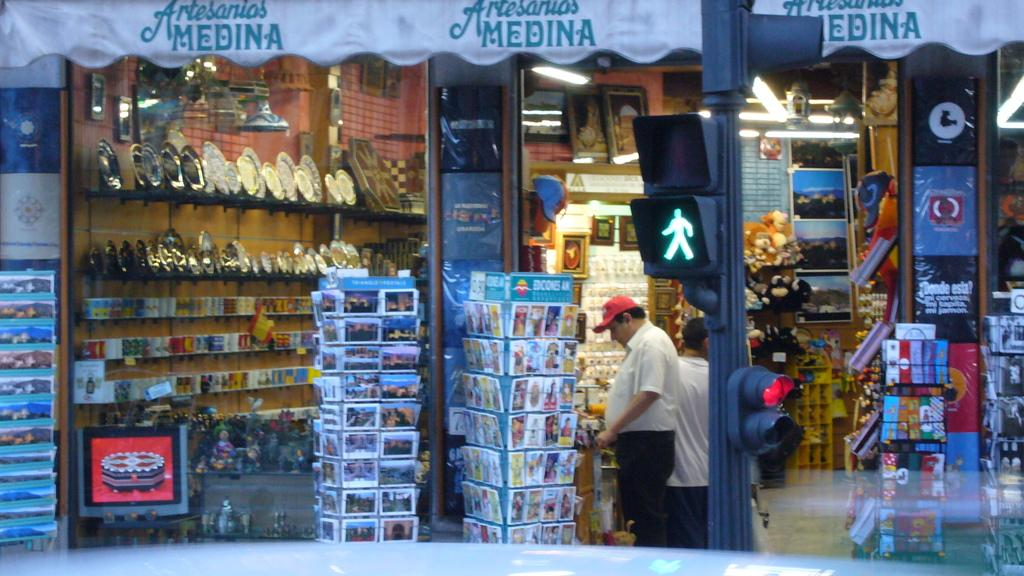<image>
Relay a brief, clear account of the picture shown. a man shopping at a place that is called Medina 